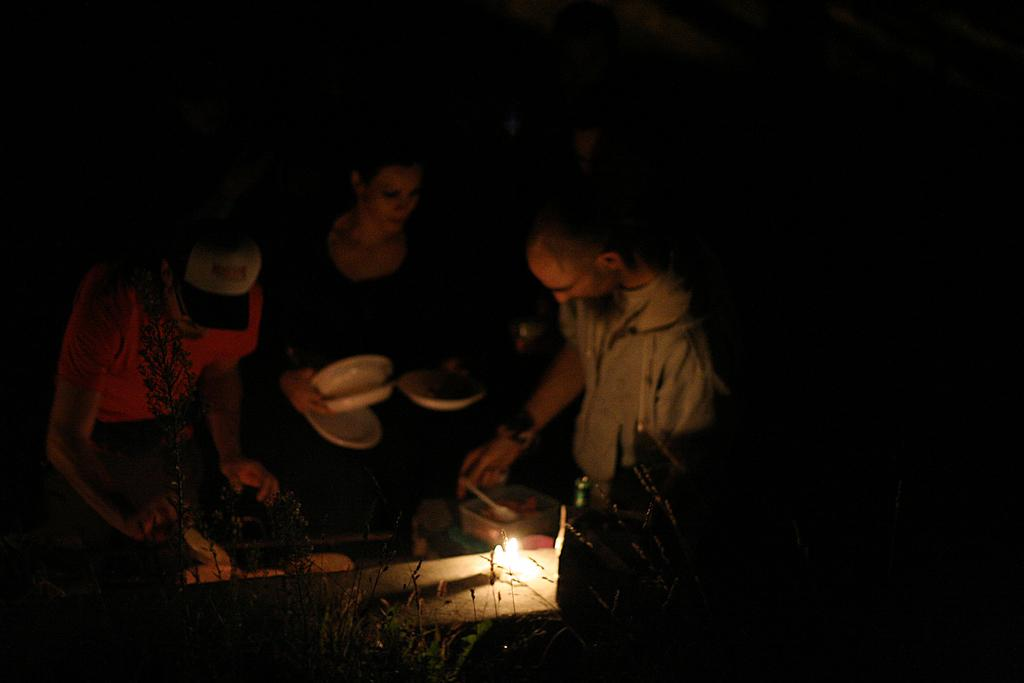How many people are in the image? There are three persons in the image. Can you describe the clothing of one of the persons? One person is wearing a cap. What is the woman in the image holding? The woman is holding plates. What can be seen providing illumination in the image? There is a light visible in the image. What type of laborer is working on the friction in the image? There is no laborer or friction present in the image. 